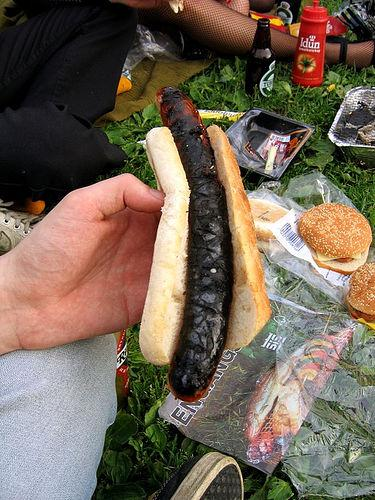Question: what is the hot dog in?
Choices:
A. Baked beans.
B. The package.
C. A bun.
D. The water cooking.
Answer with the letter. Answer: C Question: why is the food on the ground?
Choices:
A. It is for the dog.
B. It fell off table.
C. It is a picnic.
D. It is leftover scraps.
Answer with the letter. Answer: C Question: where is the food?
Choices:
A. On the table.
B. In the basket.
C. In the bag.
D. On the ground.
Answer with the letter. Answer: D Question: who is holding the hot dog?
Choices:
A. A girl.
B. A man.
C. A monkey.
D. A teenager.
Answer with the letter. Answer: B 